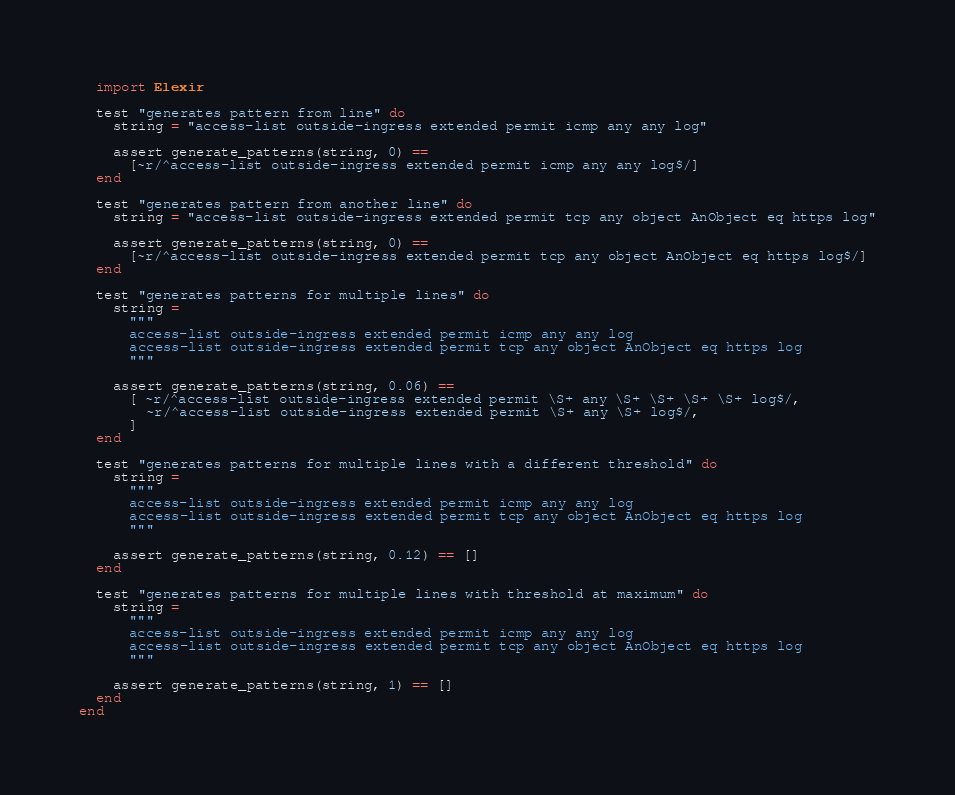Convert code to text. <code><loc_0><loc_0><loc_500><loc_500><_Elixir_>  import Elexir

  test "generates pattern from line" do
    string = "access-list outside-ingress extended permit icmp any any log"

    assert generate_patterns(string, 0) ==
      [~r/^access-list outside-ingress extended permit icmp any any log$/]
  end

  test "generates pattern from another line" do
    string = "access-list outside-ingress extended permit tcp any object AnObject eq https log"

    assert generate_patterns(string, 0) ==
      [~r/^access-list outside-ingress extended permit tcp any object AnObject eq https log$/]
  end

  test "generates patterns for multiple lines" do
    string =
      """
      access-list outside-ingress extended permit icmp any any log
      access-list outside-ingress extended permit tcp any object AnObject eq https log
      """

    assert generate_patterns(string, 0.06) ==
      [ ~r/^access-list outside-ingress extended permit \S+ any \S+ \S+ \S+ \S+ log$/,
        ~r/^access-list outside-ingress extended permit \S+ any \S+ log$/,
      ]
  end

  test "generates patterns for multiple lines with a different threshold" do
    string =
      """
      access-list outside-ingress extended permit icmp any any log
      access-list outside-ingress extended permit tcp any object AnObject eq https log
      """

    assert generate_patterns(string, 0.12) == []
  end

  test "generates patterns for multiple lines with threshold at maximum" do
    string =
      """
      access-list outside-ingress extended permit icmp any any log
      access-list outside-ingress extended permit tcp any object AnObject eq https log
      """

    assert generate_patterns(string, 1) == []
  end
end
</code> 